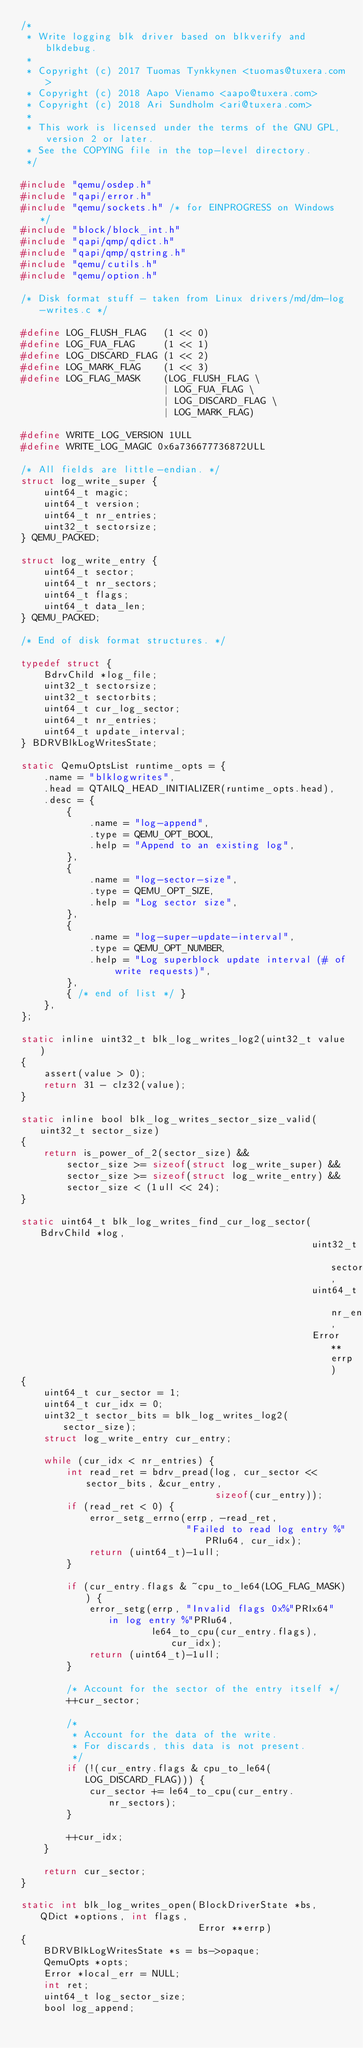<code> <loc_0><loc_0><loc_500><loc_500><_C_>/*
 * Write logging blk driver based on blkverify and blkdebug.
 *
 * Copyright (c) 2017 Tuomas Tynkkynen <tuomas@tuxera.com>
 * Copyright (c) 2018 Aapo Vienamo <aapo@tuxera.com>
 * Copyright (c) 2018 Ari Sundholm <ari@tuxera.com>
 *
 * This work is licensed under the terms of the GNU GPL, version 2 or later.
 * See the COPYING file in the top-level directory.
 */

#include "qemu/osdep.h"
#include "qapi/error.h"
#include "qemu/sockets.h" /* for EINPROGRESS on Windows */
#include "block/block_int.h"
#include "qapi/qmp/qdict.h"
#include "qapi/qmp/qstring.h"
#include "qemu/cutils.h"
#include "qemu/option.h"

/* Disk format stuff - taken from Linux drivers/md/dm-log-writes.c */

#define LOG_FLUSH_FLAG   (1 << 0)
#define LOG_FUA_FLAG     (1 << 1)
#define LOG_DISCARD_FLAG (1 << 2)
#define LOG_MARK_FLAG    (1 << 3)
#define LOG_FLAG_MASK    (LOG_FLUSH_FLAG \
                         | LOG_FUA_FLAG \
                         | LOG_DISCARD_FLAG \
                         | LOG_MARK_FLAG)

#define WRITE_LOG_VERSION 1ULL
#define WRITE_LOG_MAGIC 0x6a736677736872ULL

/* All fields are little-endian. */
struct log_write_super {
    uint64_t magic;
    uint64_t version;
    uint64_t nr_entries;
    uint32_t sectorsize;
} QEMU_PACKED;

struct log_write_entry {
    uint64_t sector;
    uint64_t nr_sectors;
    uint64_t flags;
    uint64_t data_len;
} QEMU_PACKED;

/* End of disk format structures. */

typedef struct {
    BdrvChild *log_file;
    uint32_t sectorsize;
    uint32_t sectorbits;
    uint64_t cur_log_sector;
    uint64_t nr_entries;
    uint64_t update_interval;
} BDRVBlkLogWritesState;

static QemuOptsList runtime_opts = {
    .name = "blklogwrites",
    .head = QTAILQ_HEAD_INITIALIZER(runtime_opts.head),
    .desc = {
        {
            .name = "log-append",
            .type = QEMU_OPT_BOOL,
            .help = "Append to an existing log",
        },
        {
            .name = "log-sector-size",
            .type = QEMU_OPT_SIZE,
            .help = "Log sector size",
        },
        {
            .name = "log-super-update-interval",
            .type = QEMU_OPT_NUMBER,
            .help = "Log superblock update interval (# of write requests)",
        },
        { /* end of list */ }
    },
};

static inline uint32_t blk_log_writes_log2(uint32_t value)
{
    assert(value > 0);
    return 31 - clz32(value);
}

static inline bool blk_log_writes_sector_size_valid(uint32_t sector_size)
{
    return is_power_of_2(sector_size) &&
        sector_size >= sizeof(struct log_write_super) &&
        sector_size >= sizeof(struct log_write_entry) &&
        sector_size < (1ull << 24);
}

static uint64_t blk_log_writes_find_cur_log_sector(BdrvChild *log,
                                                   uint32_t sector_size,
                                                   uint64_t nr_entries,
                                                   Error **errp)
{
    uint64_t cur_sector = 1;
    uint64_t cur_idx = 0;
    uint32_t sector_bits = blk_log_writes_log2(sector_size);
    struct log_write_entry cur_entry;

    while (cur_idx < nr_entries) {
        int read_ret = bdrv_pread(log, cur_sector << sector_bits, &cur_entry,
                                  sizeof(cur_entry));
        if (read_ret < 0) {
            error_setg_errno(errp, -read_ret,
                             "Failed to read log entry %"PRIu64, cur_idx);
            return (uint64_t)-1ull;
        }

        if (cur_entry.flags & ~cpu_to_le64(LOG_FLAG_MASK)) {
            error_setg(errp, "Invalid flags 0x%"PRIx64" in log entry %"PRIu64,
                       le64_to_cpu(cur_entry.flags), cur_idx);
            return (uint64_t)-1ull;
        }

        /* Account for the sector of the entry itself */
        ++cur_sector;

        /*
         * Account for the data of the write.
         * For discards, this data is not present.
         */
        if (!(cur_entry.flags & cpu_to_le64(LOG_DISCARD_FLAG))) {
            cur_sector += le64_to_cpu(cur_entry.nr_sectors);
        }

        ++cur_idx;
    }

    return cur_sector;
}

static int blk_log_writes_open(BlockDriverState *bs, QDict *options, int flags,
                               Error **errp)
{
    BDRVBlkLogWritesState *s = bs->opaque;
    QemuOpts *opts;
    Error *local_err = NULL;
    int ret;
    uint64_t log_sector_size;
    bool log_append;
</code> 